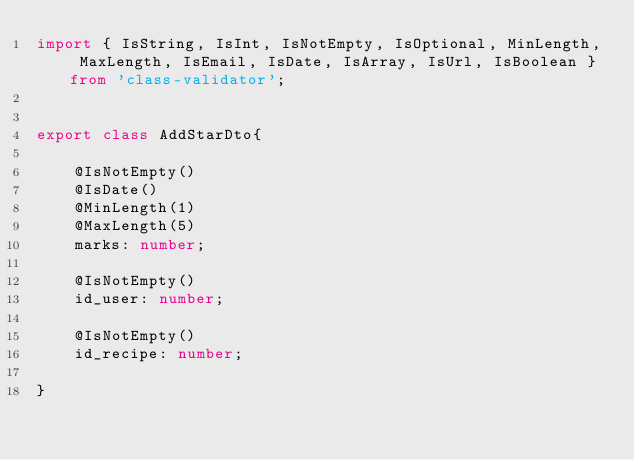Convert code to text. <code><loc_0><loc_0><loc_500><loc_500><_TypeScript_>import { IsString, IsInt, IsNotEmpty, IsOptional, MinLength, MaxLength, IsEmail, IsDate, IsArray, IsUrl, IsBoolean } from 'class-validator';


export class AddStarDto{

    @IsNotEmpty()
    @IsDate()
    @MinLength(1)
    @MaxLength(5)
    marks: number;

    @IsNotEmpty()
    id_user: number;

    @IsNotEmpty()
    id_recipe: number;

}</code> 